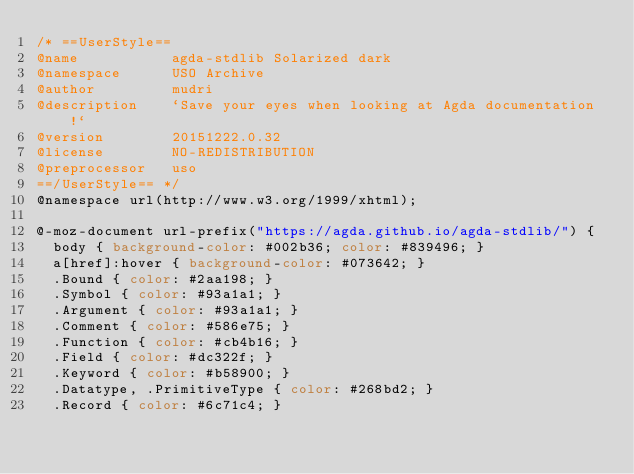<code> <loc_0><loc_0><loc_500><loc_500><_CSS_>/* ==UserStyle==
@name           agda-stdlib Solarized dark
@namespace      USO Archive
@author         mudri
@description    `Save your eyes when looking at Agda documentation!`
@version        20151222.0.32
@license        NO-REDISTRIBUTION
@preprocessor   uso
==/UserStyle== */
@namespace url(http://www.w3.org/1999/xhtml);

@-moz-document url-prefix("https://agda.github.io/agda-stdlib/") {
  body { background-color: #002b36; color: #839496; }
  a[href]:hover { background-color: #073642; }
  .Bound { color: #2aa198; }
  .Symbol { color: #93a1a1; }
  .Argument { color: #93a1a1; }
  .Comment { color: #586e75; }
  .Function { color: #cb4b16; }
  .Field { color: #dc322f; }
  .Keyword { color: #b58900; }
  .Datatype, .PrimitiveType { color: #268bd2; } 
  .Record { color: #6c71c4; }</code> 